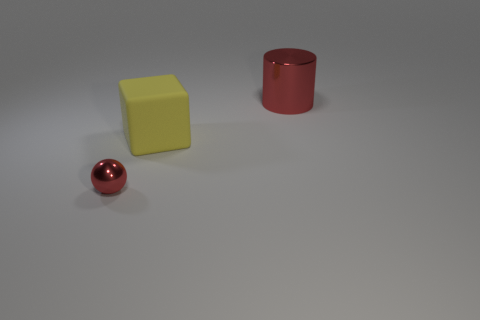Is there any other thing that has the same size as the red ball?
Your answer should be compact. No. Are there any other things that are the same color as the ball?
Provide a succinct answer. Yes. What shape is the large object that is the same color as the tiny shiny sphere?
Keep it short and to the point. Cylinder. There is a metallic cylinder; does it have the same color as the metallic thing that is in front of the cube?
Give a very brief answer. Yes. There is a red sphere that is made of the same material as the red cylinder; what size is it?
Your response must be concise. Small. The object that is the same color as the tiny sphere is what size?
Provide a succinct answer. Large. Is the color of the large cylinder the same as the tiny metal object?
Your response must be concise. Yes. There is a red metal thing in front of the red thing behind the red metal ball; is there a large yellow matte object in front of it?
Keep it short and to the point. No. What number of other objects are the same size as the yellow thing?
Your response must be concise. 1. There is a cube that is to the left of the red cylinder; is its size the same as the red thing behind the tiny object?
Provide a succinct answer. Yes. 